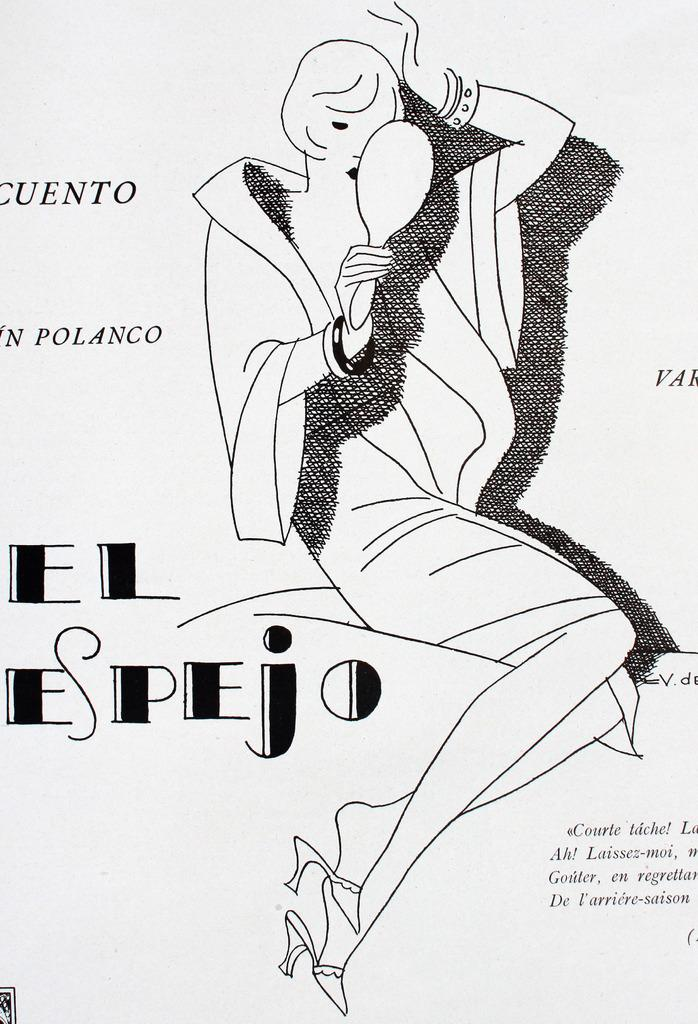What is the main subject of the paper in the image? The paper contains a picture of a woman. What is the woman in the picture holding? The woman in the picture is holding a mirror. What type of pleasure can be seen on the woman's face in the image? There is no indication of the woman's facial expression in the image, so it cannot be determined if she is experiencing pleasure. 